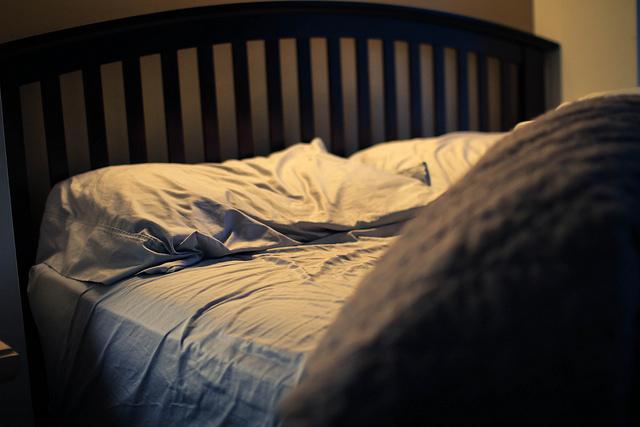How many pillows are visible in this image?
Write a very short answer. 2. Does this bed need to be made?
Quick response, please. Yes. What color are the sheets?
Short answer required. White. 